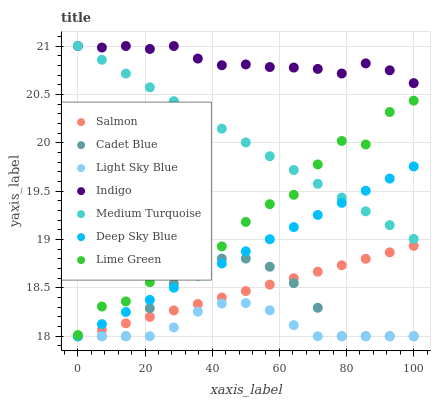Does Light Sky Blue have the minimum area under the curve?
Answer yes or no. Yes. Does Indigo have the maximum area under the curve?
Answer yes or no. Yes. Does Deep Sky Blue have the minimum area under the curve?
Answer yes or no. No. Does Deep Sky Blue have the maximum area under the curve?
Answer yes or no. No. Is Deep Sky Blue the smoothest?
Answer yes or no. Yes. Is Lime Green the roughest?
Answer yes or no. Yes. Is Indigo the smoothest?
Answer yes or no. No. Is Indigo the roughest?
Answer yes or no. No. Does Cadet Blue have the lowest value?
Answer yes or no. Yes. Does Indigo have the lowest value?
Answer yes or no. No. Does Medium Turquoise have the highest value?
Answer yes or no. Yes. Does Deep Sky Blue have the highest value?
Answer yes or no. No. Is Salmon less than Medium Turquoise?
Answer yes or no. Yes. Is Lime Green greater than Salmon?
Answer yes or no. Yes. Does Salmon intersect Deep Sky Blue?
Answer yes or no. Yes. Is Salmon less than Deep Sky Blue?
Answer yes or no. No. Is Salmon greater than Deep Sky Blue?
Answer yes or no. No. Does Salmon intersect Medium Turquoise?
Answer yes or no. No. 